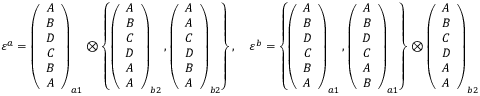Convert formula to latex. <formula><loc_0><loc_0><loc_500><loc_500>\begin{array} { r } { \varepsilon ^ { a } = \left ( \begin{array} { c } { A } \\ { B } \\ { D } \\ { C } \\ { B } \\ { A } \end{array} \right ) _ { a 1 } \otimes \left \{ \left ( \begin{array} { c } { A } \\ { B } \\ { C } \\ { D } \\ { A } \\ { A } \end{array} \right ) _ { b 2 } , \left ( \begin{array} { c } { A } \\ { A } \\ { C } \\ { D } \\ { B } \\ { A } \end{array} \right ) _ { b 2 } \right \} , \quad \varepsilon ^ { b } = \left \{ \left ( \begin{array} { c } { A } \\ { B } \\ { D } \\ { C } \\ { B } \\ { A } \end{array} \right ) _ { a 1 } , \left ( \begin{array} { c } { A } \\ { B } \\ { D } \\ { C } \\ { A } \\ { B } \end{array} \right ) _ { a 1 } \right \} \otimes \left ( \begin{array} { c } { A } \\ { B } \\ { C } \\ { D } \\ { A } \\ { A } \end{array} \right ) _ { b 2 } } \end{array}</formula> 